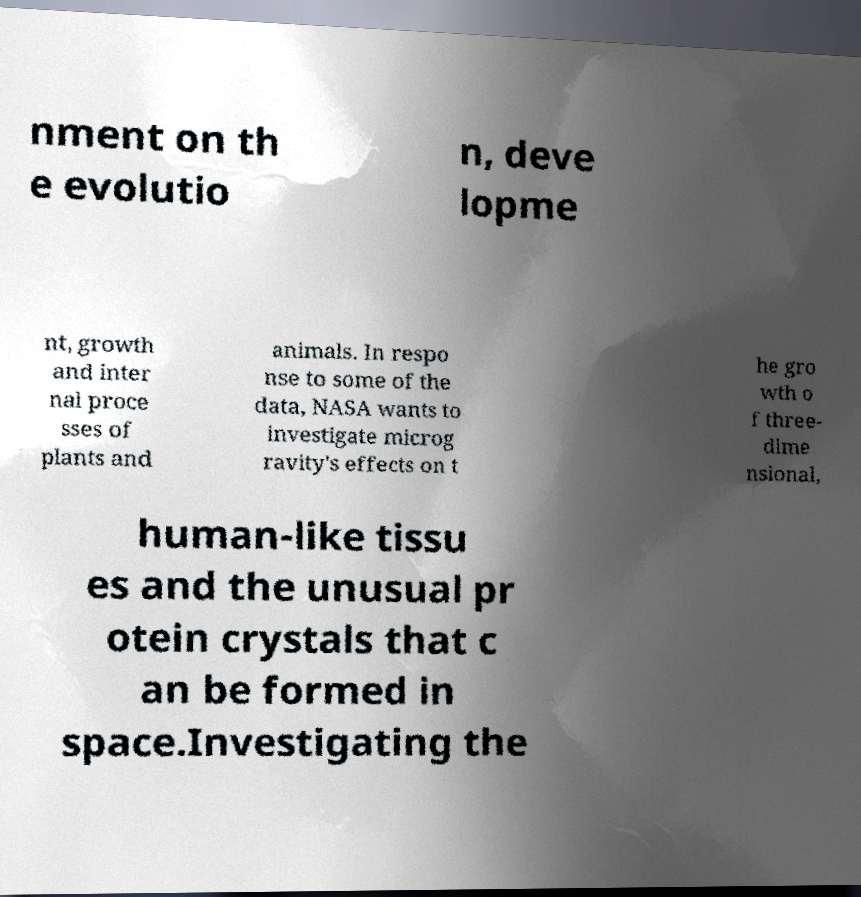Can you accurately transcribe the text from the provided image for me? nment on th e evolutio n, deve lopme nt, growth and inter nal proce sses of plants and animals. In respo nse to some of the data, NASA wants to investigate microg ravity's effects on t he gro wth o f three- dime nsional, human-like tissu es and the unusual pr otein crystals that c an be formed in space.Investigating the 